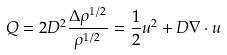<formula> <loc_0><loc_0><loc_500><loc_500>Q = 2 D ^ { 2 } { \frac { \Delta \rho ^ { 1 / 2 } } { \rho ^ { 1 / 2 } } } = { \frac { 1 } 2 } u ^ { 2 } + D \nabla \cdot u</formula> 